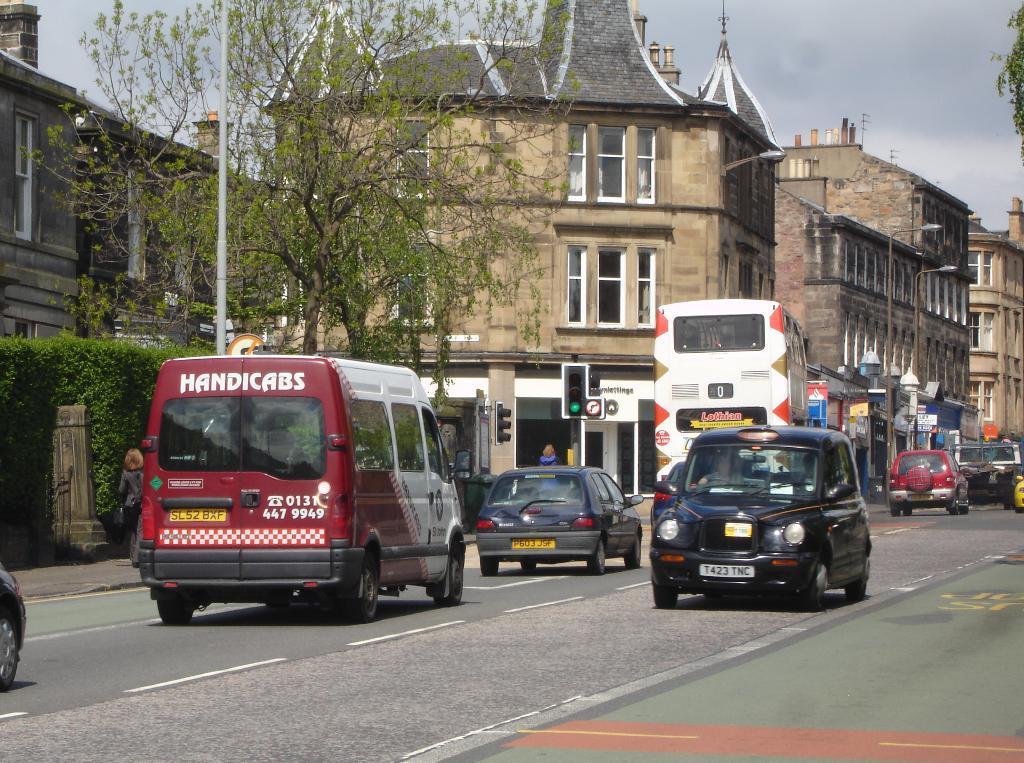How would you summarize this image in a sentence or two? In the image in the center we can see few vehicles on the road. In the background we can see the sky,clouds,buildings,windows,poles,trees,banners,sign boards,plants,roof,wall,traffic light and one person standing. 